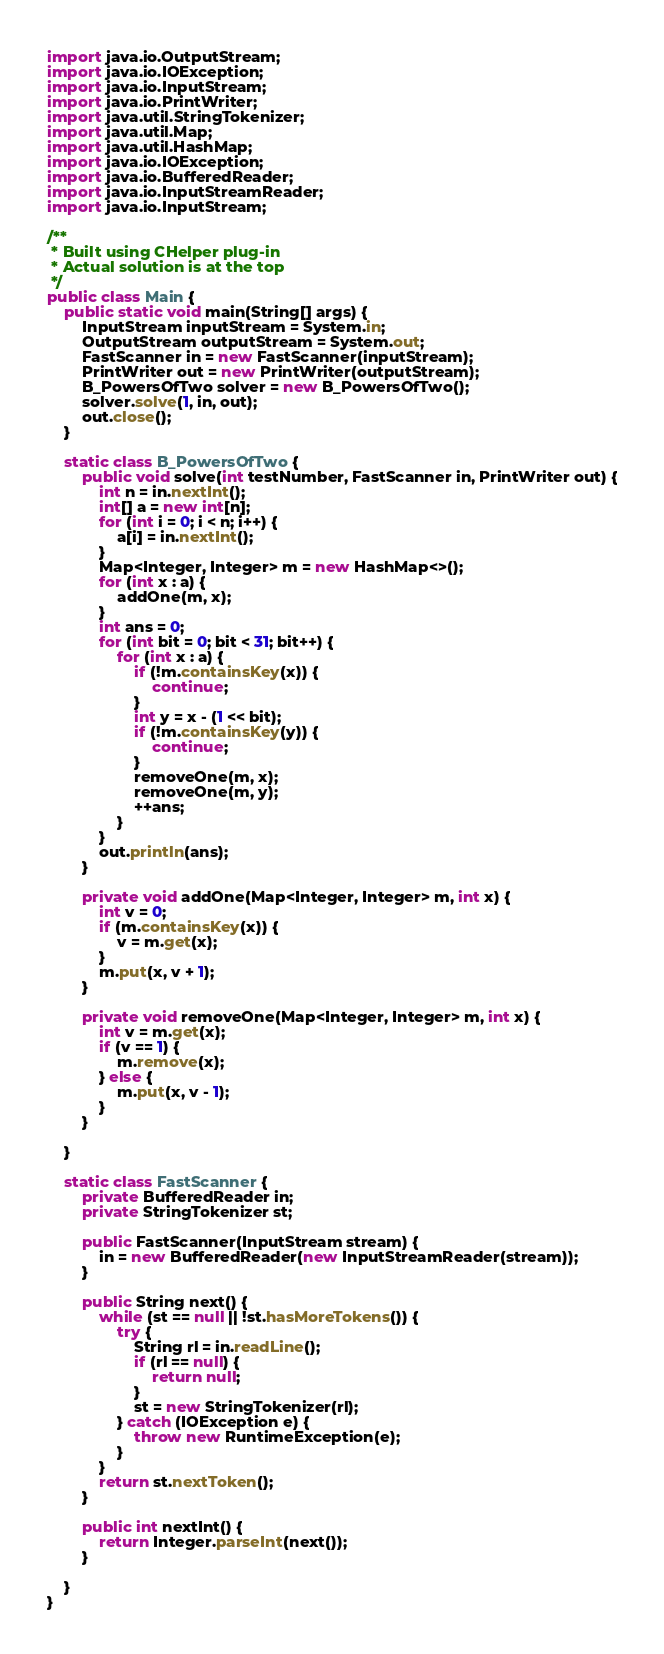Convert code to text. <code><loc_0><loc_0><loc_500><loc_500><_Java_>import java.io.OutputStream;
import java.io.IOException;
import java.io.InputStream;
import java.io.PrintWriter;
import java.util.StringTokenizer;
import java.util.Map;
import java.util.HashMap;
import java.io.IOException;
import java.io.BufferedReader;
import java.io.InputStreamReader;
import java.io.InputStream;

/**
 * Built using CHelper plug-in
 * Actual solution is at the top
 */
public class Main {
	public static void main(String[] args) {
		InputStream inputStream = System.in;
		OutputStream outputStream = System.out;
		FastScanner in = new FastScanner(inputStream);
		PrintWriter out = new PrintWriter(outputStream);
		B_PowersOfTwo solver = new B_PowersOfTwo();
		solver.solve(1, in, out);
		out.close();
	}

	static class B_PowersOfTwo {
		public void solve(int testNumber, FastScanner in, PrintWriter out) {
			int n = in.nextInt();
			int[] a = new int[n];
			for (int i = 0; i < n; i++) {
				a[i] = in.nextInt();
			}
			Map<Integer, Integer> m = new HashMap<>();
			for (int x : a) {
				addOne(m, x);
			}
			int ans = 0;
			for (int bit = 0; bit < 31; bit++) {
				for (int x : a) {
					if (!m.containsKey(x)) {
						continue;
					}
					int y = x - (1 << bit);
					if (!m.containsKey(y)) {
						continue;
					}
					removeOne(m, x);
					removeOne(m, y);
					++ans;
				}
			}
			out.println(ans);
		}

		private void addOne(Map<Integer, Integer> m, int x) {
			int v = 0;
			if (m.containsKey(x)) {
				v = m.get(x);
			}
			m.put(x, v + 1);
		}

		private void removeOne(Map<Integer, Integer> m, int x) {
			int v = m.get(x);
			if (v == 1) {
				m.remove(x);
			} else {
				m.put(x, v - 1);
			}
		}

	}

	static class FastScanner {
		private BufferedReader in;
		private StringTokenizer st;

		public FastScanner(InputStream stream) {
			in = new BufferedReader(new InputStreamReader(stream));
		}

		public String next() {
			while (st == null || !st.hasMoreTokens()) {
				try {
					String rl = in.readLine();
					if (rl == null) {
						return null;
					}
					st = new StringTokenizer(rl);
				} catch (IOException e) {
					throw new RuntimeException(e);
				}
			}
			return st.nextToken();
		}

		public int nextInt() {
			return Integer.parseInt(next());
		}

	}
}

</code> 